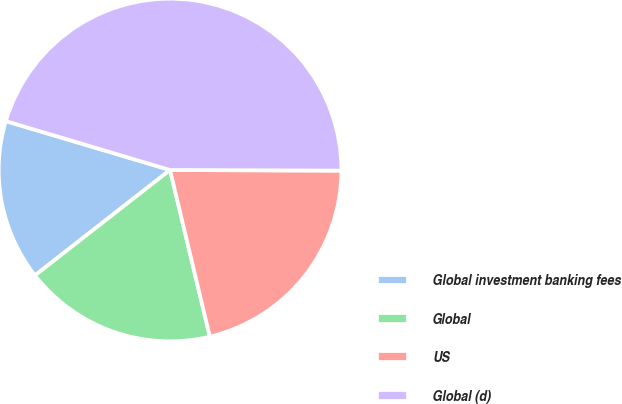<chart> <loc_0><loc_0><loc_500><loc_500><pie_chart><fcel>Global investment banking fees<fcel>Global<fcel>US<fcel>Global (d)<nl><fcel>15.15%<fcel>18.18%<fcel>21.21%<fcel>45.45%<nl></chart> 